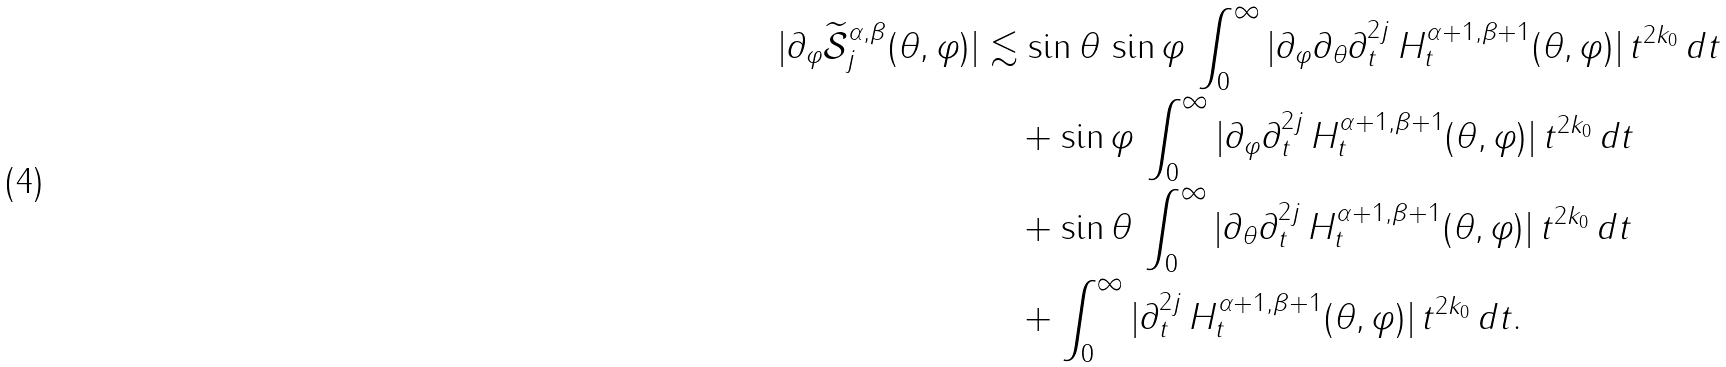Convert formula to latex. <formula><loc_0><loc_0><loc_500><loc_500>| \partial _ { \varphi } \widetilde { \mathcal { S } } _ { j } ^ { \alpha , \beta } ( \theta , \varphi ) | & \lesssim \sin \theta \, \sin \varphi \, \int _ { 0 } ^ { \infty } | \partial _ { \varphi } \partial _ { \theta } \partial _ { t } ^ { 2 j } \, H _ { t } ^ { \alpha + 1 , \beta + 1 } ( \theta , \varphi ) | \, t ^ { 2 k _ { 0 } } \, d t \\ & \quad + \sin \varphi \, \int _ { 0 } ^ { \infty } | \partial _ { \varphi } \partial _ { t } ^ { 2 j } \, H _ { t } ^ { \alpha + 1 , \beta + 1 } ( \theta , \varphi ) | \, t ^ { 2 k _ { 0 } } \, d t \\ & \quad + \sin \theta \, \int _ { 0 } ^ { \infty } | \partial _ { \theta } \partial _ { t } ^ { 2 j } \, H _ { t } ^ { \alpha + 1 , \beta + 1 } ( \theta , \varphi ) | \, t ^ { 2 k _ { 0 } } \, d t \\ & \quad + \int _ { 0 } ^ { \infty } | \partial _ { t } ^ { 2 j } \, H _ { t } ^ { \alpha + 1 , \beta + 1 } ( \theta , \varphi ) | \, t ^ { 2 k _ { 0 } } \, d t .</formula> 